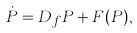Convert formula to latex. <formula><loc_0><loc_0><loc_500><loc_500>\dot { P } = D _ { f } P + F ( P ) ,</formula> 